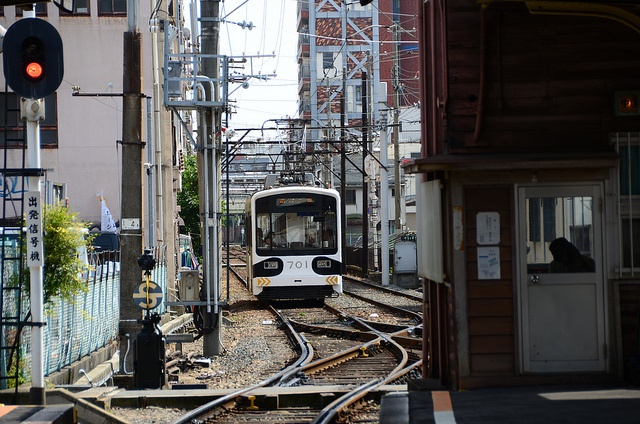Describe the objects in this image and their specific colors. I can see train in black, gray, darkgray, and lightgray tones, traffic light in black, darkgray, gray, and salmon tones, people in black and gray tones, people in black and gray tones, and people in black and gray tones in this image. 